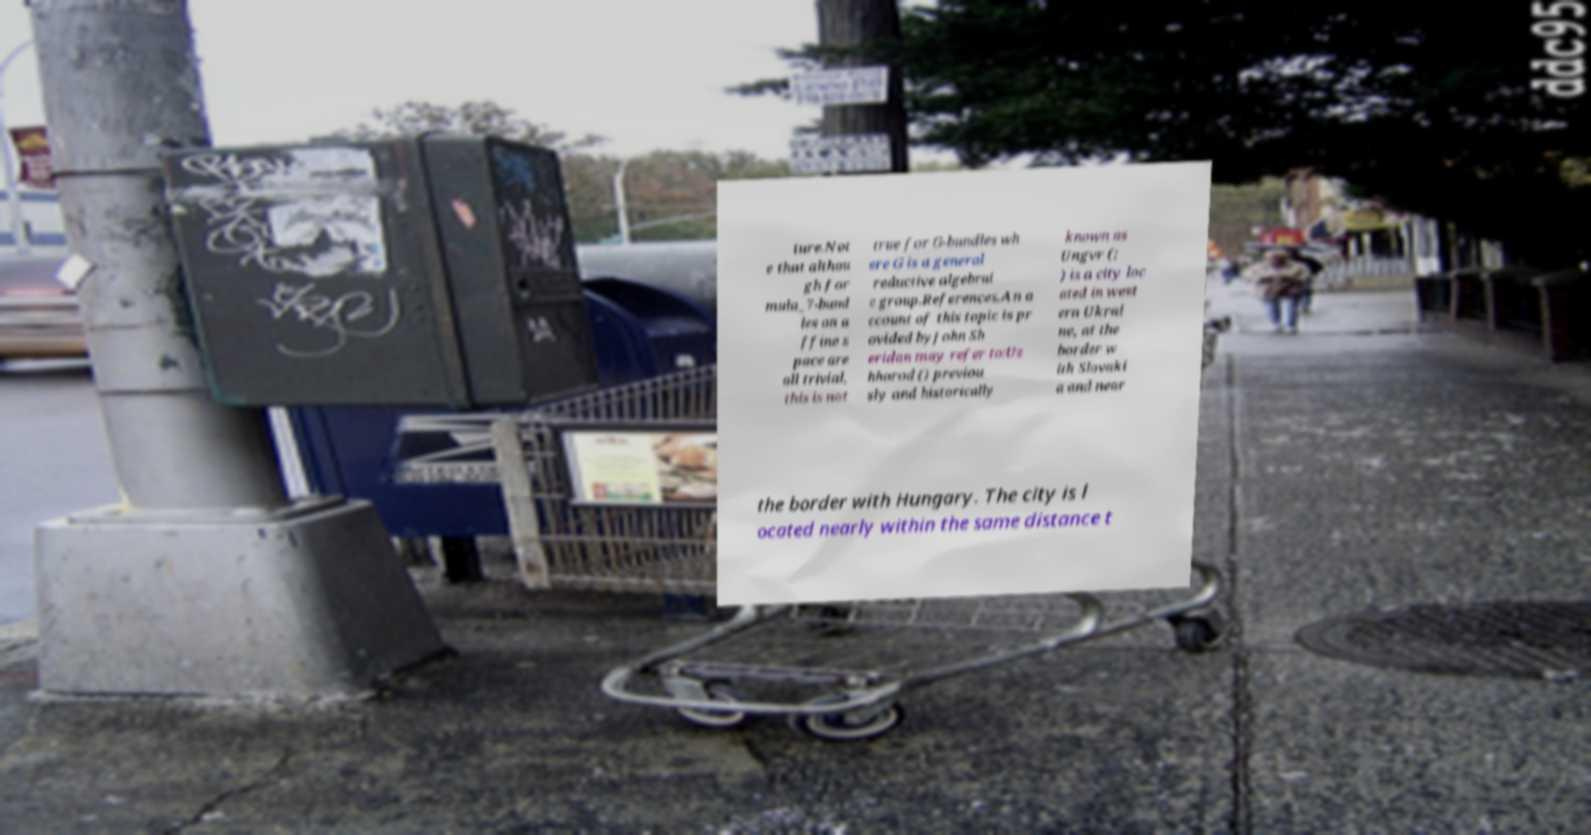Could you extract and type out the text from this image? ture.Not e that althou gh for mula_7-bund les on a ffine s pace are all trivial, this is not true for G-bundles wh ere G is a general reductive algebrai c group.References.An a ccount of this topic is pr ovided byJohn Sh eridan may refer to:Uz hhorod () previou sly and historically known as Ungvr (; ) is a city loc ated in west ern Ukrai ne, at the border w ith Slovaki a and near the border with Hungary. The city is l ocated nearly within the same distance t 